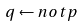Convert formula to latex. <formula><loc_0><loc_0><loc_500><loc_500>q \leftarrow n o t p</formula> 